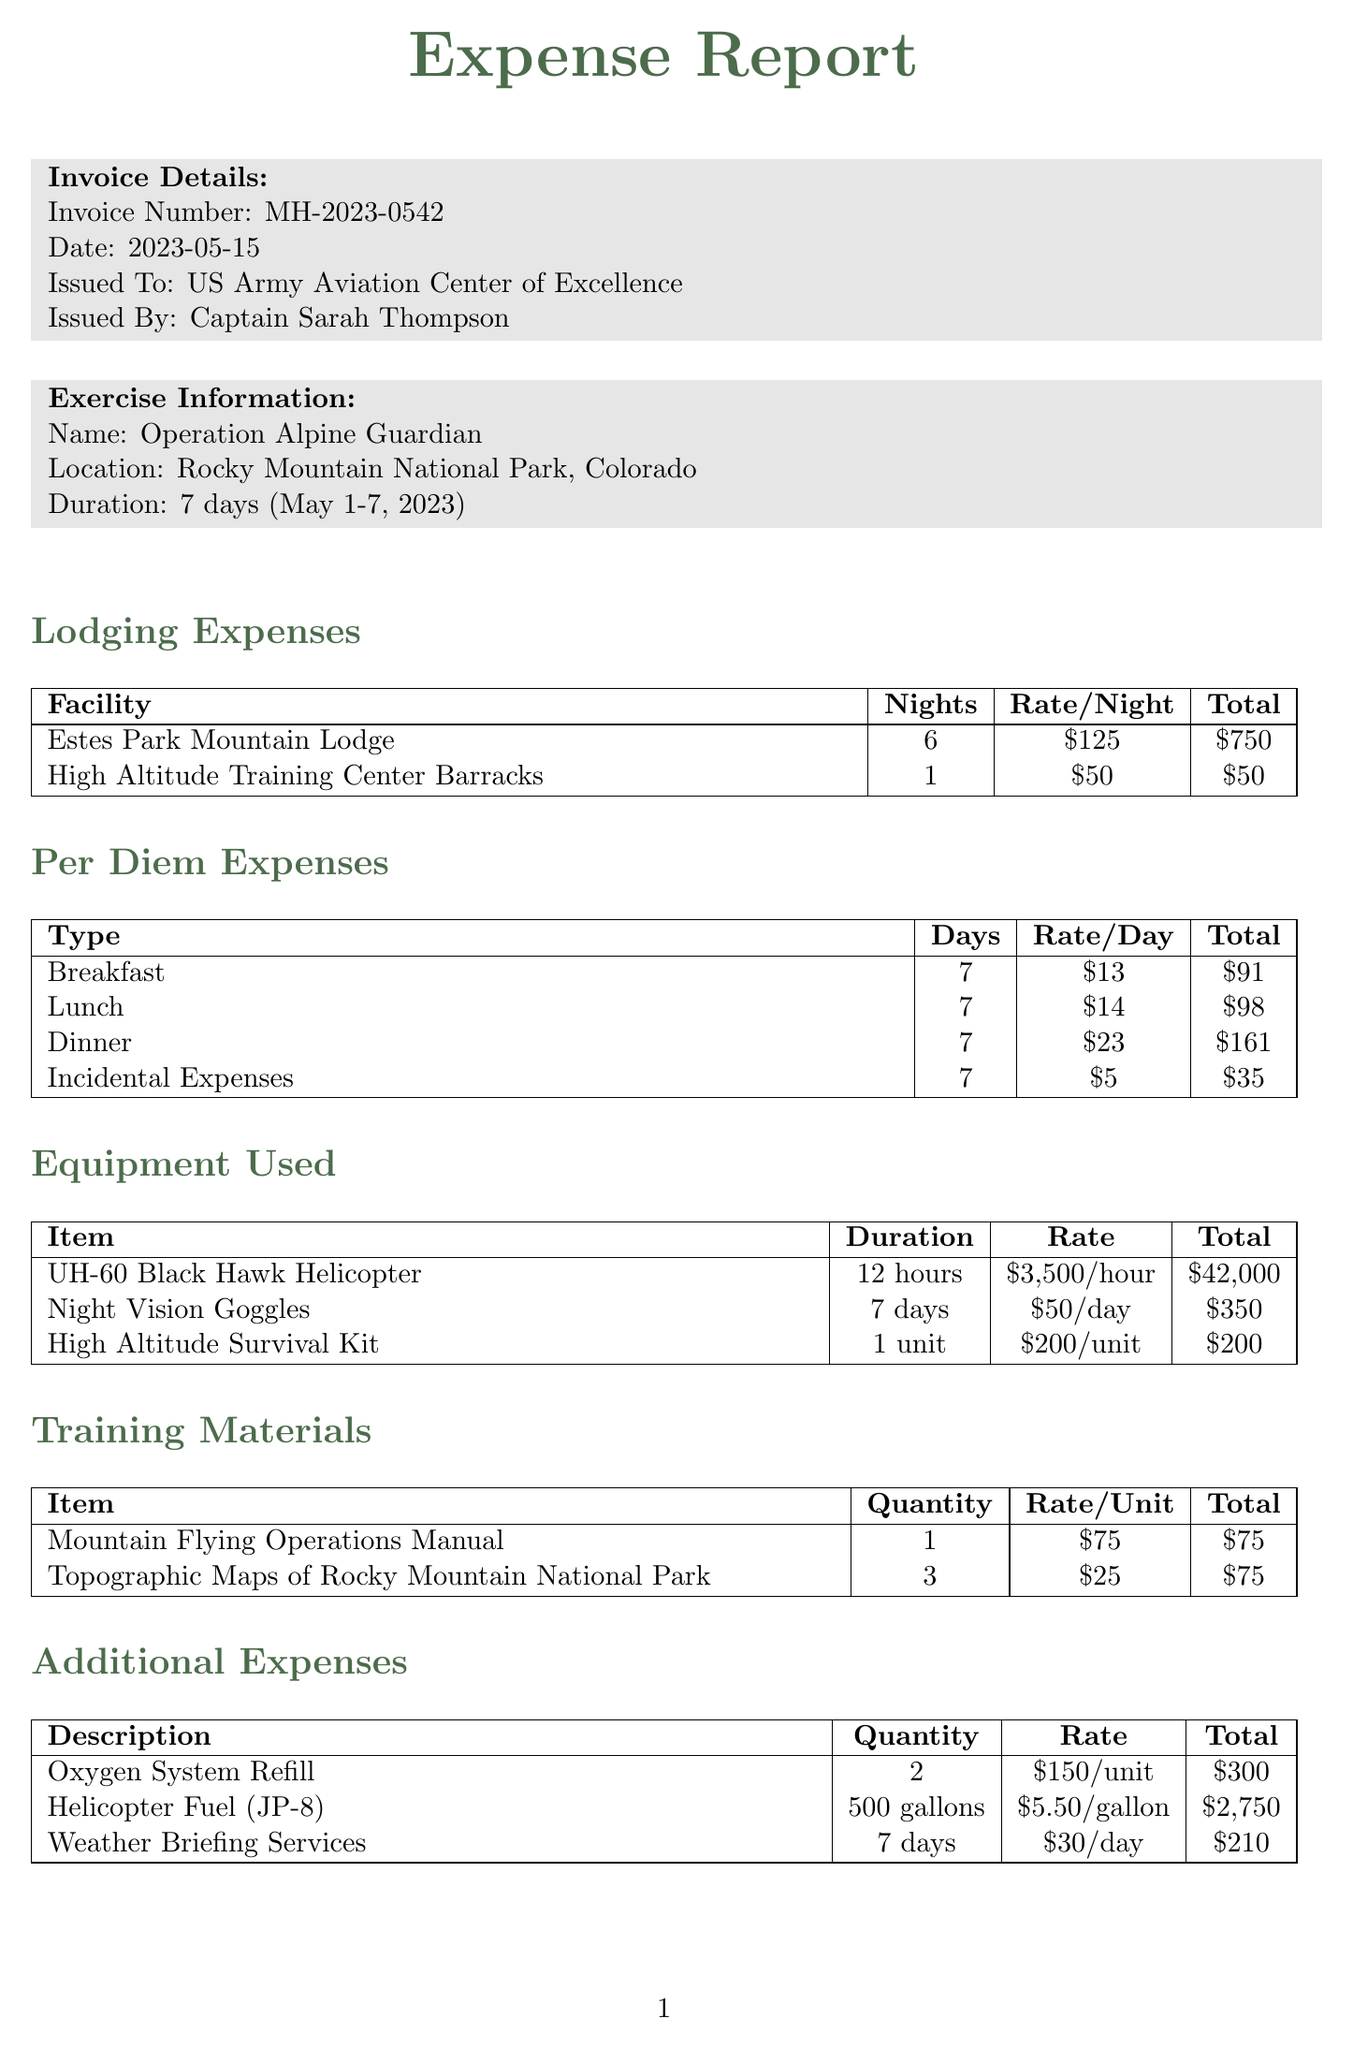What is the invoice number? The invoice number is listed in the invoice details section.
Answer: MH-2023-0542 What is the total lodging expense? The total lodging expense is calculated by summing the lodging costs from the lodging expenses section.
Answer: $800 How many days was the training exercise conducted? The duration of the training exercise is stated in the exercise information section.
Answer: 7 days What facility was used for lodging for the most nights? The facility with the highest number of nights is noted in the lodging expenses table.
Answer: Estes Park Mountain Lodge What is the total amount for dinner per diem expenses? The total for dinner is found in the per diem expenses section, specifically for dinner.
Answer: $161 Which item had the highest total cost in equipment used? The equipment item with the highest cost is highlighted in the equipment used table.
Answer: UH-60 Black Hawk Helicopter What was the daily rate for incidental expenses? The daily rate for incidental expenses is specified in the per diem expenses section.
Answer: $5 How much was spent on weather briefing services? The amount spent on weather briefing services can be found in the additional expenses section.
Answer: $210 What is the grand total of all expenses? The grand total is presented at the end of the document, summarizing all categories of expenses.
Answer: $47,145 